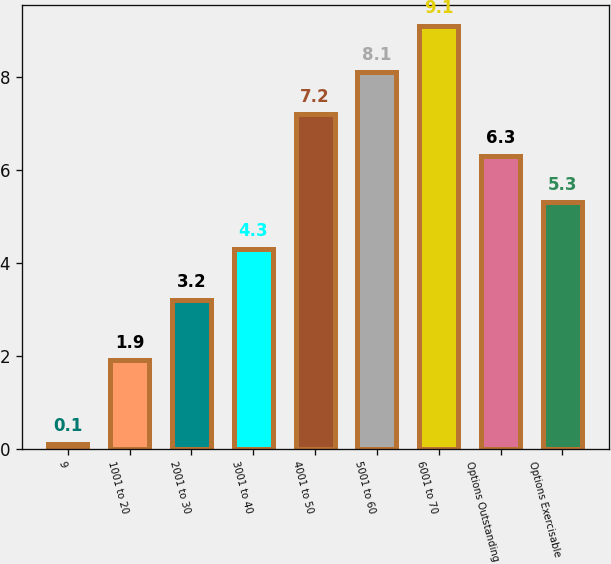Convert chart to OTSL. <chart><loc_0><loc_0><loc_500><loc_500><bar_chart><fcel>9<fcel>1001 to 20<fcel>2001 to 30<fcel>3001 to 40<fcel>4001 to 50<fcel>5001 to 60<fcel>6001 to 70<fcel>Options Outstanding<fcel>Options Exercisable<nl><fcel>0.1<fcel>1.9<fcel>3.2<fcel>4.3<fcel>7.2<fcel>8.1<fcel>9.1<fcel>6.3<fcel>5.3<nl></chart> 